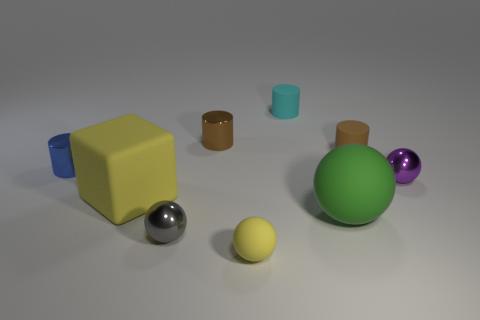Subtract all cubes. How many objects are left? 8 Add 4 small gray metal objects. How many small gray metal objects are left? 5 Add 4 blue rubber spheres. How many blue rubber spheres exist? 4 Subtract 0 purple cubes. How many objects are left? 9 Subtract all matte balls. Subtract all big green balls. How many objects are left? 6 